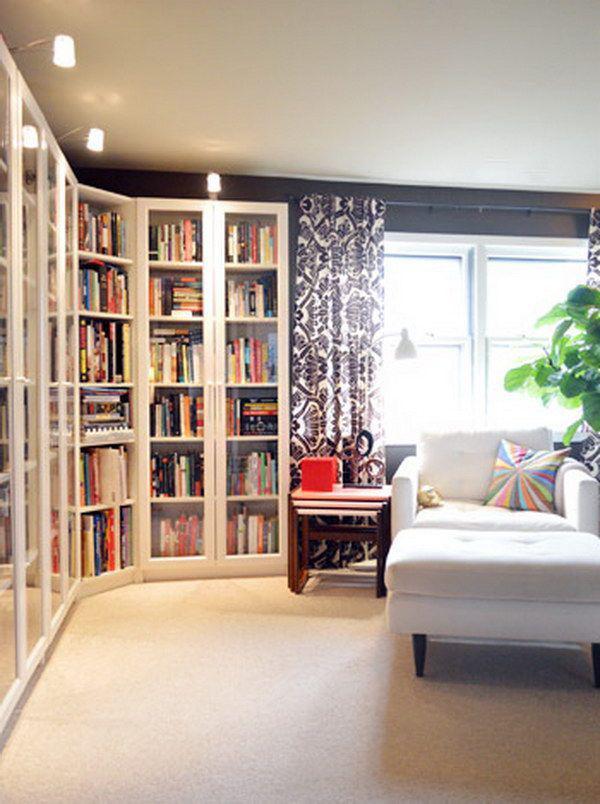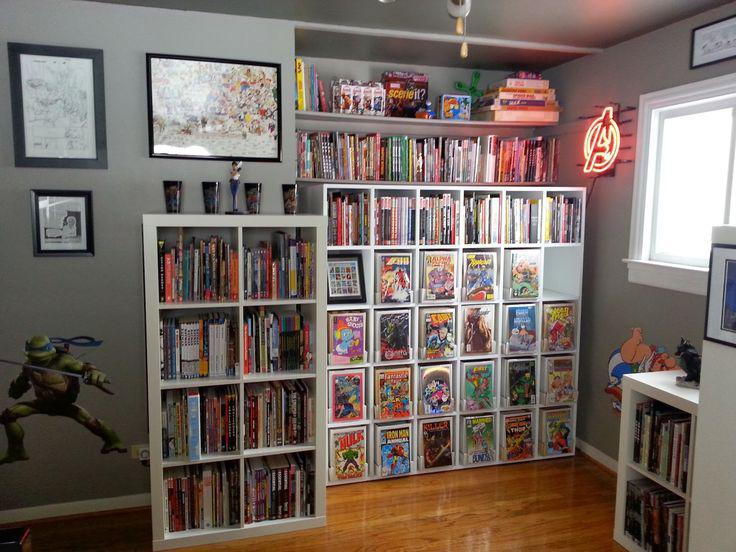The first image is the image on the left, the second image is the image on the right. For the images shown, is this caption "An image shows a hanging corner shelf style without back or sides." true? Answer yes or no. No. 